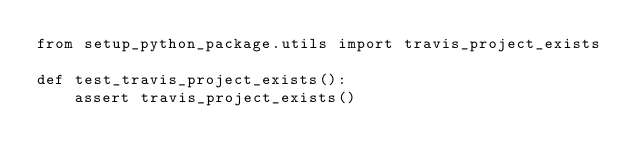Convert code to text. <code><loc_0><loc_0><loc_500><loc_500><_Python_>from setup_python_package.utils import travis_project_exists

def test_travis_project_exists():
    assert travis_project_exists()</code> 